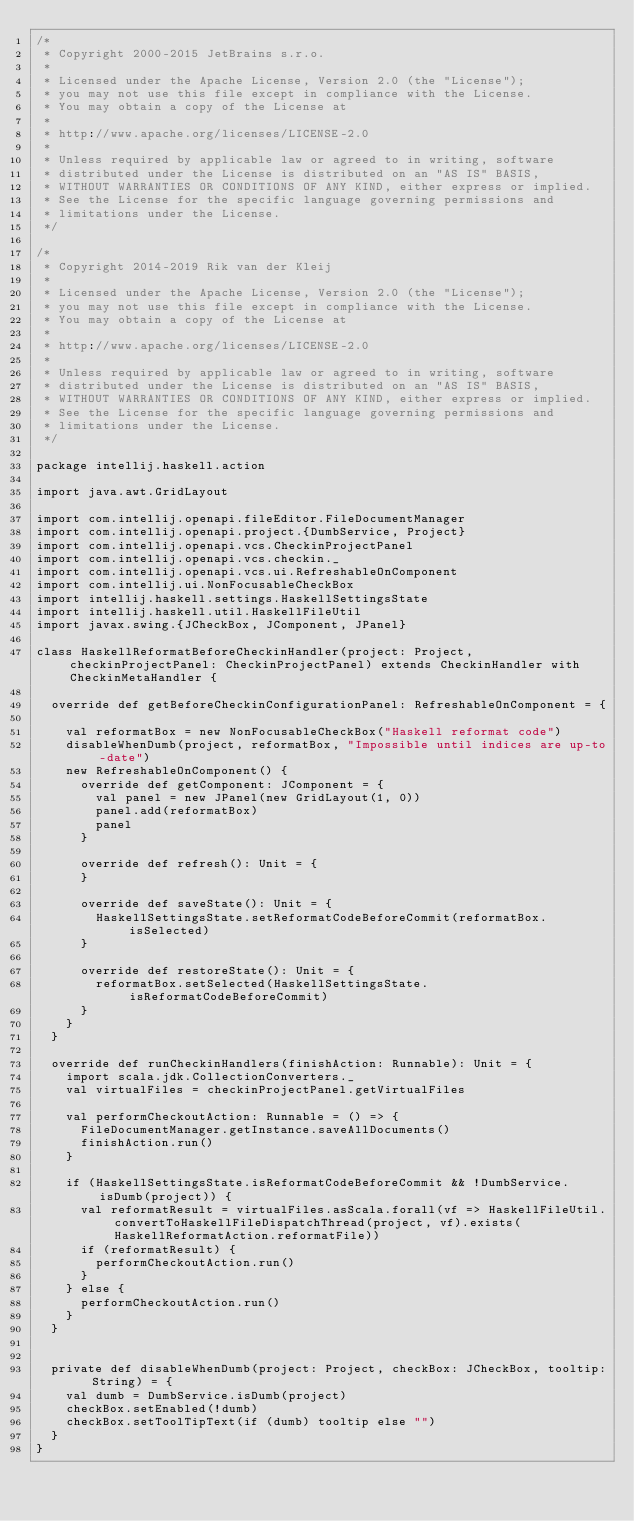<code> <loc_0><loc_0><loc_500><loc_500><_Scala_>/*
 * Copyright 2000-2015 JetBrains s.r.o.
 *
 * Licensed under the Apache License, Version 2.0 (the "License");
 * you may not use this file except in compliance with the License.
 * You may obtain a copy of the License at
 *
 * http://www.apache.org/licenses/LICENSE-2.0
 *
 * Unless required by applicable law or agreed to in writing, software
 * distributed under the License is distributed on an "AS IS" BASIS,
 * WITHOUT WARRANTIES OR CONDITIONS OF ANY KIND, either express or implied.
 * See the License for the specific language governing permissions and
 * limitations under the License.
 */

/*
 * Copyright 2014-2019 Rik van der Kleij
 *
 * Licensed under the Apache License, Version 2.0 (the "License");
 * you may not use this file except in compliance with the License.
 * You may obtain a copy of the License at
 *
 * http://www.apache.org/licenses/LICENSE-2.0
 *
 * Unless required by applicable law or agreed to in writing, software
 * distributed under the License is distributed on an "AS IS" BASIS,
 * WITHOUT WARRANTIES OR CONDITIONS OF ANY KIND, either express or implied.
 * See the License for the specific language governing permissions and
 * limitations under the License.
 */

package intellij.haskell.action

import java.awt.GridLayout

import com.intellij.openapi.fileEditor.FileDocumentManager
import com.intellij.openapi.project.{DumbService, Project}
import com.intellij.openapi.vcs.CheckinProjectPanel
import com.intellij.openapi.vcs.checkin._
import com.intellij.openapi.vcs.ui.RefreshableOnComponent
import com.intellij.ui.NonFocusableCheckBox
import intellij.haskell.settings.HaskellSettingsState
import intellij.haskell.util.HaskellFileUtil
import javax.swing.{JCheckBox, JComponent, JPanel}

class HaskellReformatBeforeCheckinHandler(project: Project, checkinProjectPanel: CheckinProjectPanel) extends CheckinHandler with CheckinMetaHandler {

  override def getBeforeCheckinConfigurationPanel: RefreshableOnComponent = {

    val reformatBox = new NonFocusableCheckBox("Haskell reformat code")
    disableWhenDumb(project, reformatBox, "Impossible until indices are up-to-date")
    new RefreshableOnComponent() {
      override def getComponent: JComponent = {
        val panel = new JPanel(new GridLayout(1, 0))
        panel.add(reformatBox)
        panel
      }

      override def refresh(): Unit = {
      }

      override def saveState(): Unit = {
        HaskellSettingsState.setReformatCodeBeforeCommit(reformatBox.isSelected)
      }

      override def restoreState(): Unit = {
        reformatBox.setSelected(HaskellSettingsState.isReformatCodeBeforeCommit)
      }
    }
  }

  override def runCheckinHandlers(finishAction: Runnable): Unit = {
    import scala.jdk.CollectionConverters._
    val virtualFiles = checkinProjectPanel.getVirtualFiles

    val performCheckoutAction: Runnable = () => {
      FileDocumentManager.getInstance.saveAllDocuments()
      finishAction.run()
    }

    if (HaskellSettingsState.isReformatCodeBeforeCommit && !DumbService.isDumb(project)) {
      val reformatResult = virtualFiles.asScala.forall(vf => HaskellFileUtil.convertToHaskellFileDispatchThread(project, vf).exists(HaskellReformatAction.reformatFile))
      if (reformatResult) {
        performCheckoutAction.run()
      }
    } else {
      performCheckoutAction.run()
    }
  }


  private def disableWhenDumb(project: Project, checkBox: JCheckBox, tooltip: String) = {
    val dumb = DumbService.isDumb(project)
    checkBox.setEnabled(!dumb)
    checkBox.setToolTipText(if (dumb) tooltip else "")
  }
}
</code> 